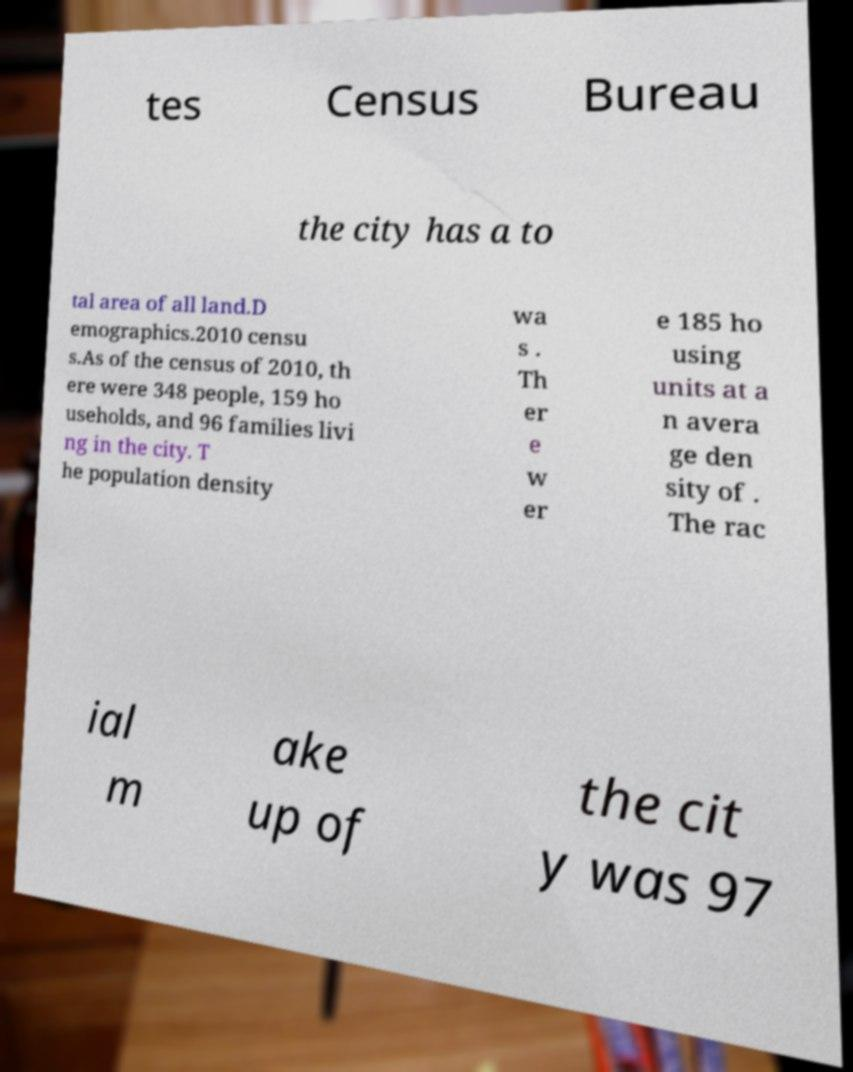Can you read and provide the text displayed in the image?This photo seems to have some interesting text. Can you extract and type it out for me? tes Census Bureau the city has a to tal area of all land.D emographics.2010 censu s.As of the census of 2010, th ere were 348 people, 159 ho useholds, and 96 families livi ng in the city. T he population density wa s . Th er e w er e 185 ho using units at a n avera ge den sity of . The rac ial m ake up of the cit y was 97 